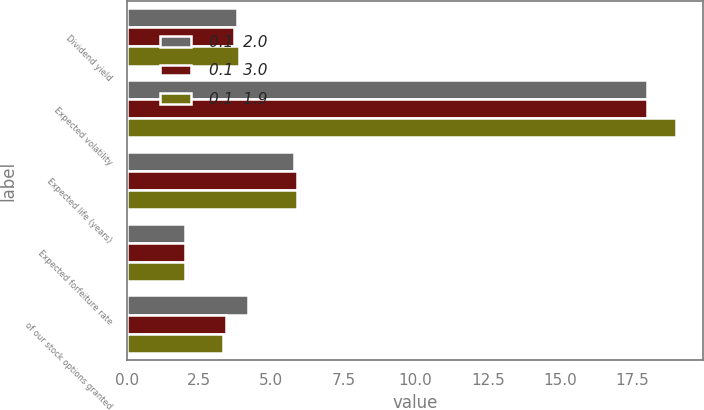Convert chart to OTSL. <chart><loc_0><loc_0><loc_500><loc_500><stacked_bar_chart><ecel><fcel>Dividend yield<fcel>Expected volatility<fcel>Expected life (years)<fcel>Expected forfeiture rate<fcel>of our stock options granted<nl><fcel>0.1  2.0<fcel>3.8<fcel>18<fcel>5.8<fcel>2<fcel>4.18<nl><fcel>0.1  3.0<fcel>3.7<fcel>18<fcel>5.9<fcel>2<fcel>3.45<nl><fcel>0.1  1.9<fcel>3.9<fcel>19<fcel>5.9<fcel>2<fcel>3.34<nl></chart> 